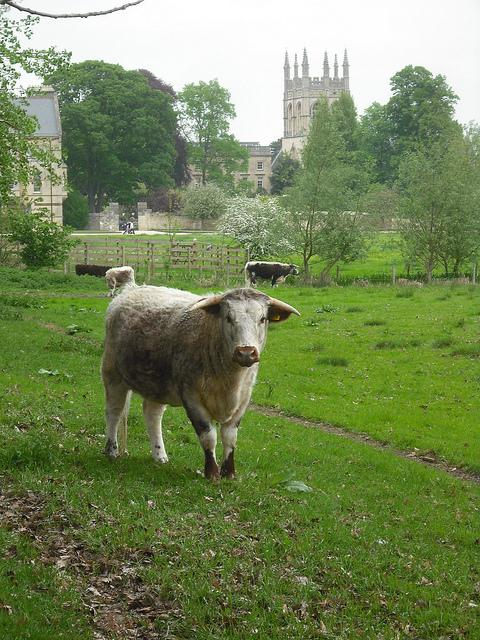What type of animal is present on the grass?

Choices:
A) dogs
B) cats
C) sheep
D) cows cows 